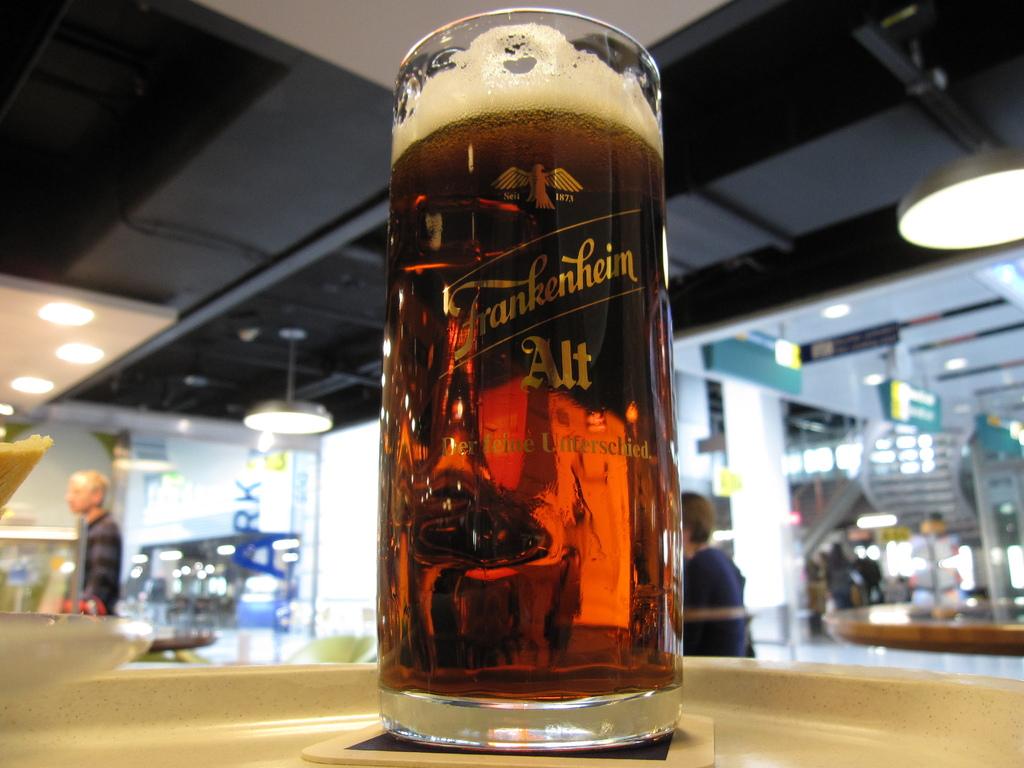What does it say on the centre of the glass?
Provide a short and direct response. Frankenhein. 